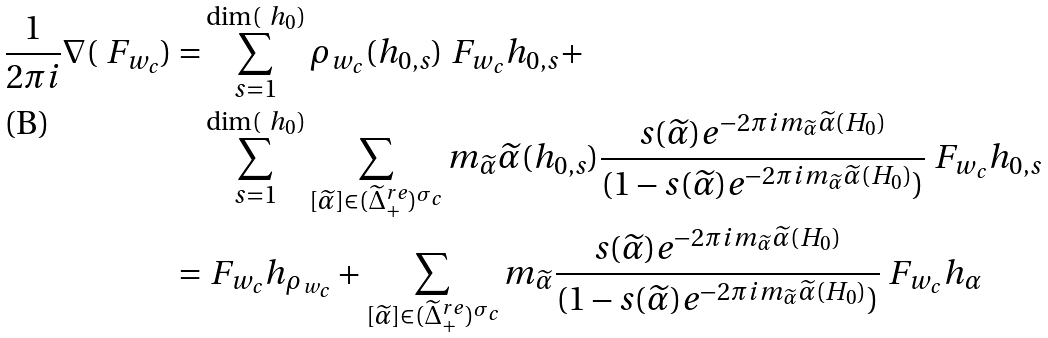Convert formula to latex. <formula><loc_0><loc_0><loc_500><loc_500>\frac { 1 } { 2 \pi i } \nabla ( \ F _ { w _ { c } } ) = & \sum _ { s = 1 } ^ { \dim ( \ h _ { 0 } ) } \rho _ { w _ { c } } ( h _ { 0 , s } ) \ F _ { w _ { c } } h _ { 0 , s } + \\ & \sum _ { s = 1 } ^ { \dim ( \ h _ { 0 } ) } \sum _ { [ \widetilde { \alpha } ] \in ( \widetilde { \Delta } ^ { r e } _ { + } ) ^ { \sigma _ { c } } } m _ { \widetilde { \alpha } } \widetilde { \alpha } ( h _ { 0 , s } ) \frac { s ( \widetilde { \alpha } ) e ^ { - 2 \pi i m _ { \widetilde { \alpha } } \widetilde { \alpha } ( H _ { 0 } ) } } { ( 1 - s ( \widetilde { \alpha } ) e ^ { - 2 \pi i m _ { \widetilde { \alpha } } \widetilde { \alpha } ( H _ { 0 } ) } ) } \ F _ { w _ { c } } h _ { 0 , s } \\ = & \ F _ { w _ { c } } h _ { \rho _ { w _ { c } } } + \sum _ { [ \widetilde { \alpha } ] \in ( \widetilde { \Delta } ^ { r e } _ { + } ) ^ { \sigma _ { c } } } m _ { \widetilde { \alpha } } \frac { s ( \widetilde { \alpha } ) e ^ { - 2 \pi i m _ { \widetilde { \alpha } } \widetilde { \alpha } ( H _ { 0 } ) } } { ( 1 - s ( \widetilde { \alpha } ) e ^ { - 2 \pi i m _ { \widetilde { \alpha } } \widetilde { \alpha } ( H _ { 0 } ) } ) } \ F _ { w _ { c } } h _ { \alpha }</formula> 